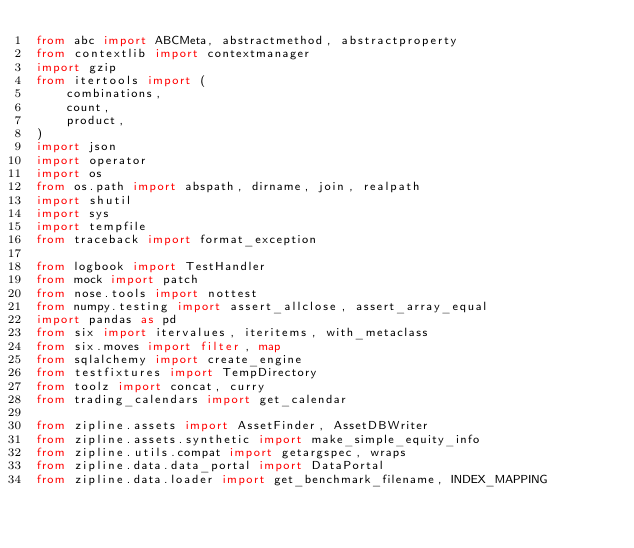Convert code to text. <code><loc_0><loc_0><loc_500><loc_500><_Python_>from abc import ABCMeta, abstractmethod, abstractproperty
from contextlib import contextmanager
import gzip
from itertools import (
    combinations,
    count,
    product,
)
import json
import operator
import os
from os.path import abspath, dirname, join, realpath
import shutil
import sys
import tempfile
from traceback import format_exception

from logbook import TestHandler
from mock import patch
from nose.tools import nottest
from numpy.testing import assert_allclose, assert_array_equal
import pandas as pd
from six import itervalues, iteritems, with_metaclass
from six.moves import filter, map
from sqlalchemy import create_engine
from testfixtures import TempDirectory
from toolz import concat, curry
from trading_calendars import get_calendar

from zipline.assets import AssetFinder, AssetDBWriter
from zipline.assets.synthetic import make_simple_equity_info
from zipline.utils.compat import getargspec, wraps
from zipline.data.data_portal import DataPortal
from zipline.data.loader import get_benchmark_filename, INDEX_MAPPING</code> 